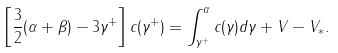Convert formula to latex. <formula><loc_0><loc_0><loc_500><loc_500>\left [ \frac { 3 } { 2 } ( \alpha + \beta ) - 3 \gamma ^ { + } \right ] c ( \gamma ^ { + } ) = \int _ { \gamma ^ { + } } ^ { \alpha } c ( \gamma ) d \gamma + V - V _ { * } .</formula> 